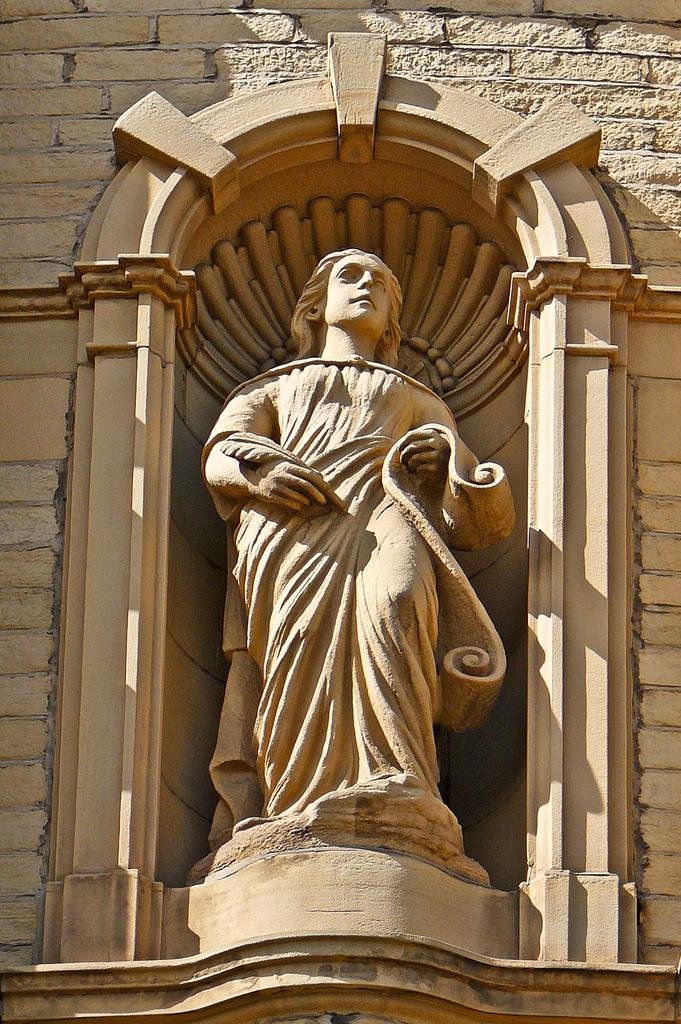Who or what is the main subject in the image? There is a person in the image. Can you describe the position of the person in the image? The person is in the middle of the image. What can be seen in the background of the image? There is a wall in the background of the image. What type of cloth is the person using to sew with a needle in the image? There is no cloth or needle present in the image; it only features a person in the middle of the image with a wall in the background. 